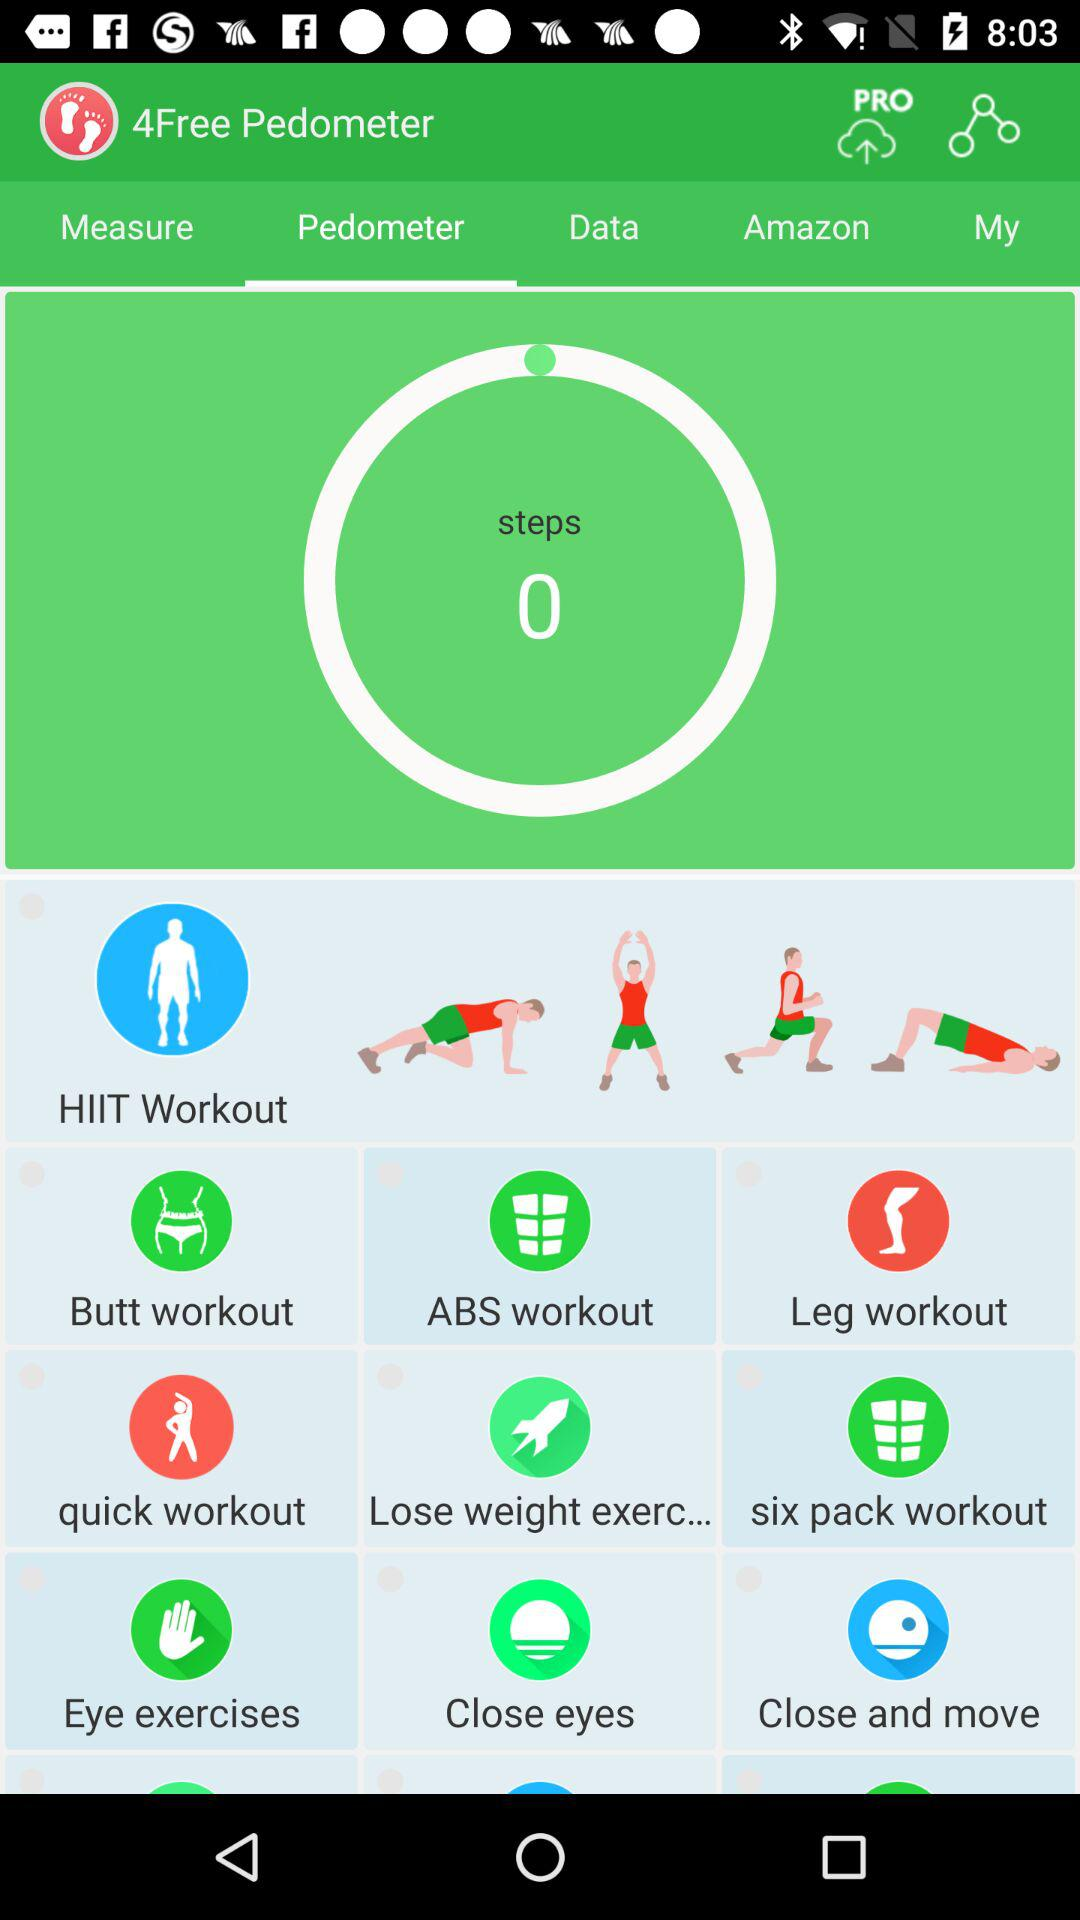What is the name of the application? The name of the application is "4Free Pedometer". 